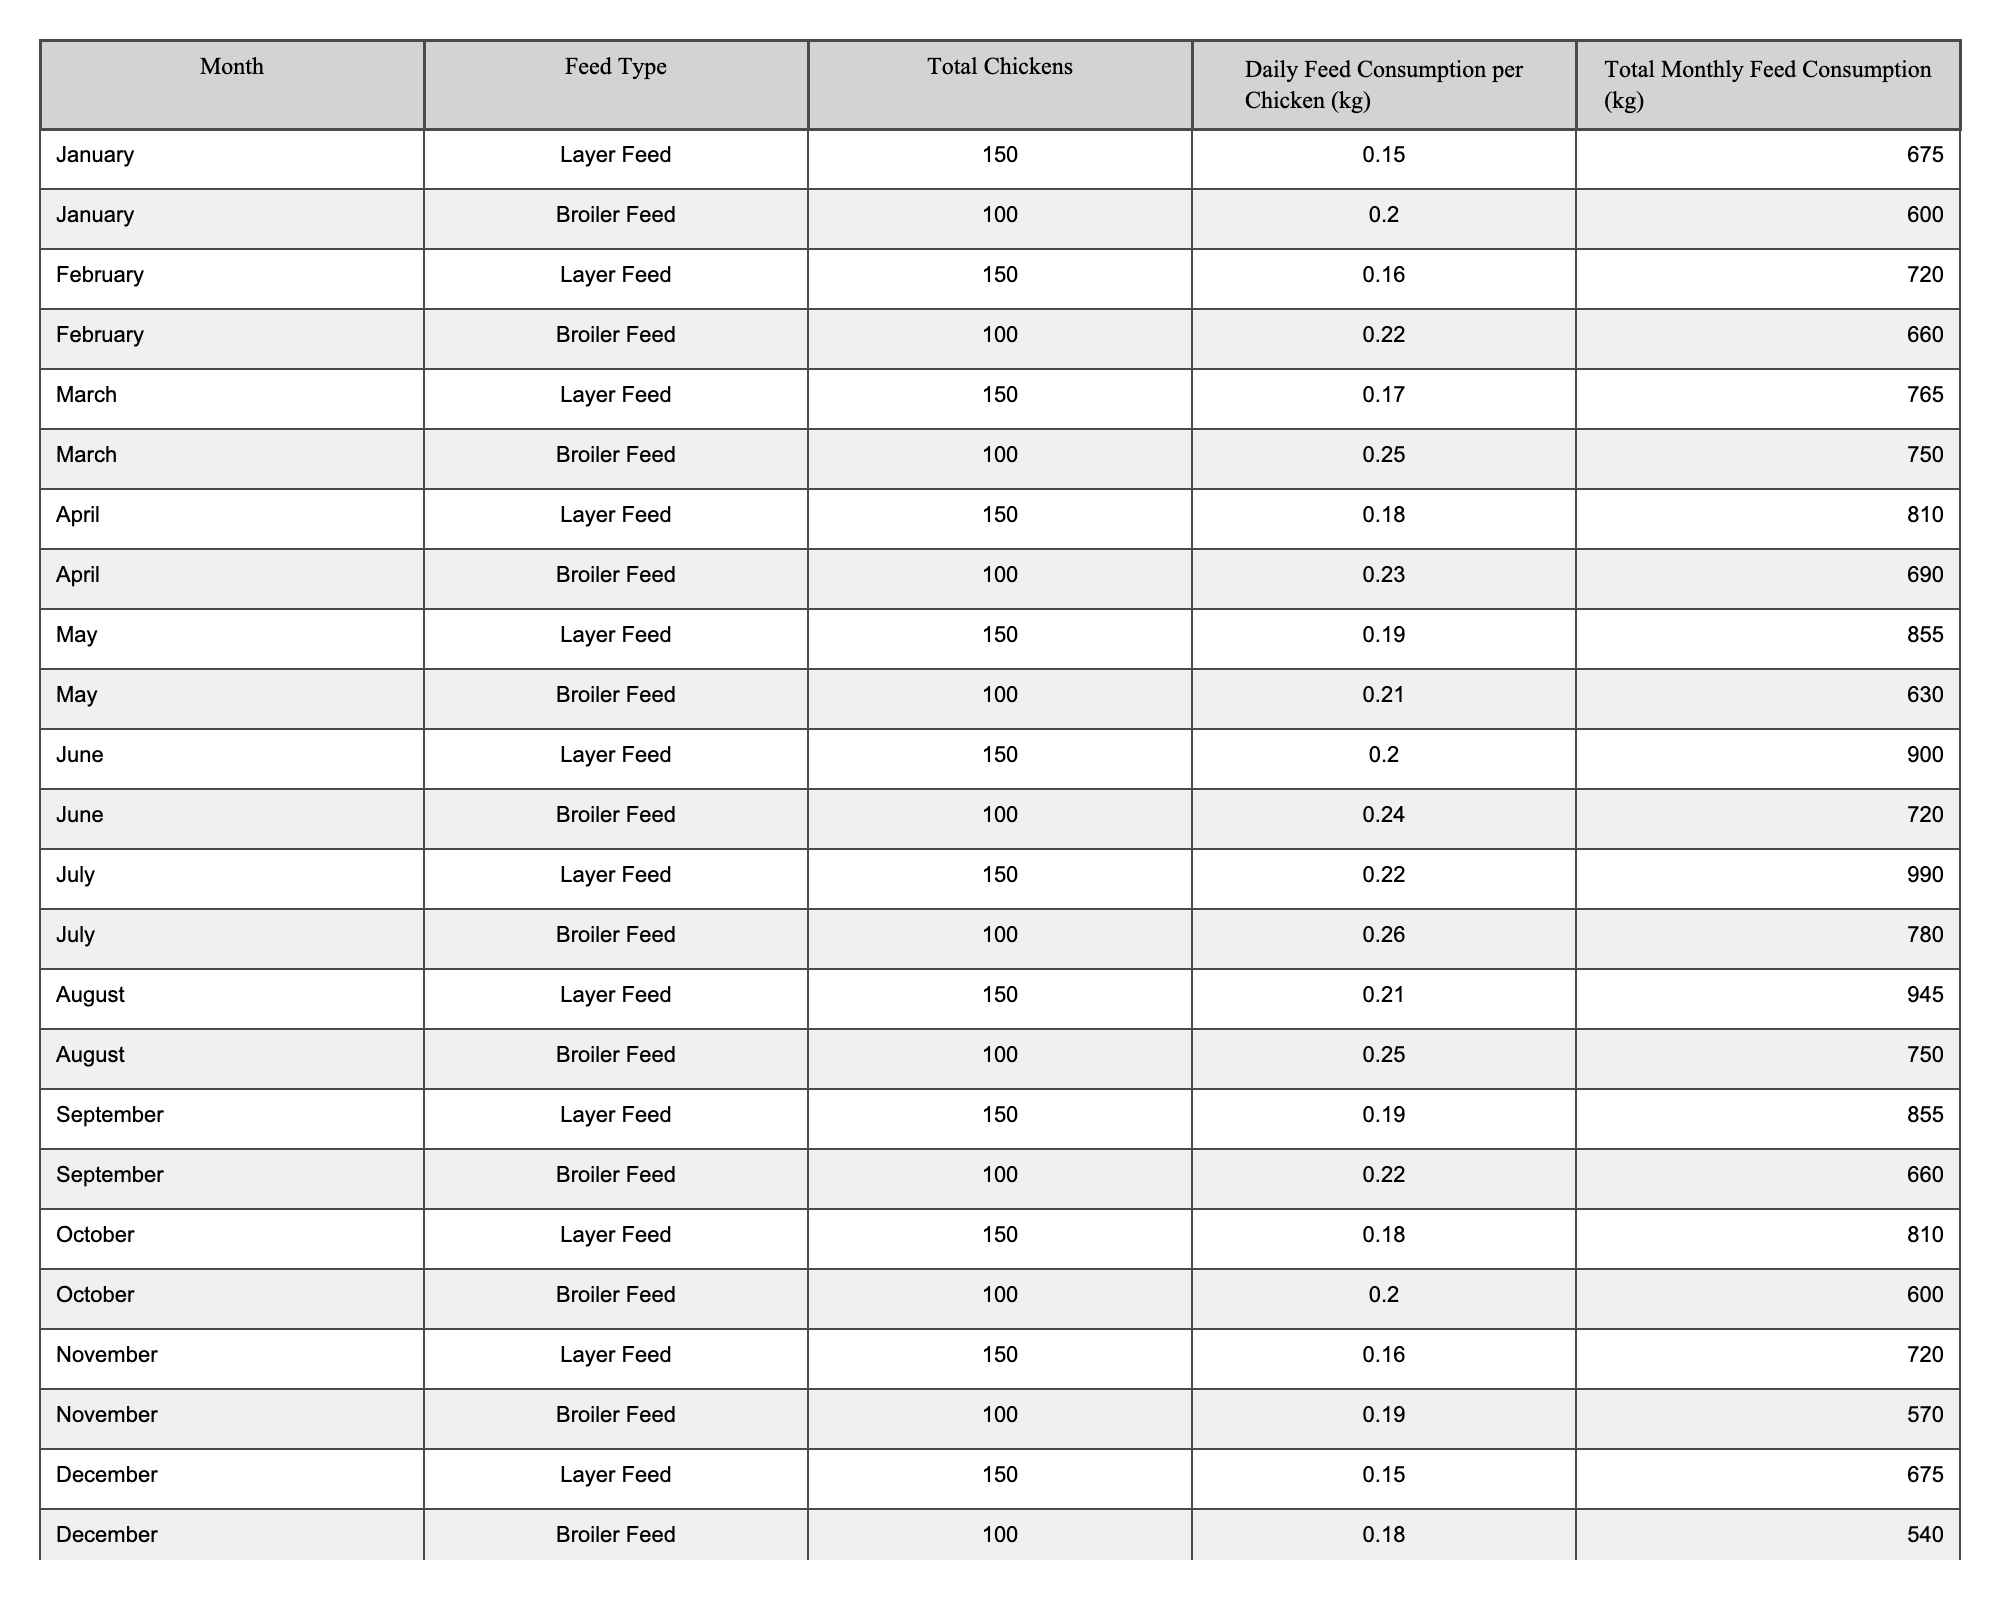What was the total monthly feed consumption for Layer Feed in March? From the table, the total monthly feed consumption for Layer Feed in March is listed directly as 765 kg.
Answer: 765 kg What is the average daily feed consumption per chicken for Broiler Feed over the year? The daily feed consumption per chicken for Broiler Feed is 0.20, 0.22, 0.25, 0.23, 0.21, 0.24, 0.26, 0.25, 0.22, 0.20, 0.19, and 0.18 kg. Adding these values gives 2.57 kg. Dividing by 12 months results in an average of 2.57/12 = 0.2142 kg.
Answer: 0.21 kg What month had the highest total monthly feed consumption for Layer Feed? By examining the total monthly feed consumptions for Layer Feed, the highest value is 990 kg in July.
Answer: July Was the total monthly feed consumption for Broiler Feed higher in February or in April? The total monthly feed consumption for Broiler Feed in February is 660 kg and in April is 690 kg. Since 690 kg is greater than 660 kg, it is concluded that April had a higher consumption.
Answer: Yes, April was higher What is the difference between the total monthly feed consumption of Layer Feed in May and December? The total monthly feed consumption for Layer Feed in May is 855 kg and in December is 675 kg. The difference is calculated as 855 kg - 675 kg = 180 kg.
Answer: 180 kg What total monthly feed consumption do we see for all Breeder's chickens in September? The total monthly feed consumption for Layer Feed in September is 855 kg and for Broiler Feed is 660 kg. Adding these together gives 855 kg + 660 kg = 1515 kg.
Answer: 1515 kg Which Feed Type had higher daily feed consumption per chicken in October? In October, the daily feed consumption for Layer Feed is 0.18 kg and for Broiler Feed is 0.20 kg. Since 0.20 kg is greater than 0.18 kg, Broiler Feed had higher consumption.
Answer: Broiler Feed had higher consumption How much does total monthly feed consumption fluctuate for Layer Feed from the highest month to the lowest month? The highest total for Layer Feed is in July at 990 kg and the lowest is in December at 675 kg. The fluctuation is 990 kg - 675 kg = 315 kg.
Answer: 315 kg What percentage decrease in feed consumption is observed from February to March for Broiler Feed? The feed consumption for Broiler Feed in February is 660 kg and in March is 750 kg. The change is 750 kg - 660 kg = 90 kg. To find the percentage, (90 kg / 660 kg) * 100 = 13.64%.
Answer: 13.64% Did the total monthly feed consumption for all chickens increase or decrease from June to July? The total monthly feed consumption for June is (900 kg for Layer + 720 kg for Broiler = 1620 kg) and for July is (990 kg for Layer + 780 kg for Broiler = 1770 kg). Since 1770 kg is greater than 1620 kg, it increased.
Answer: It increased 